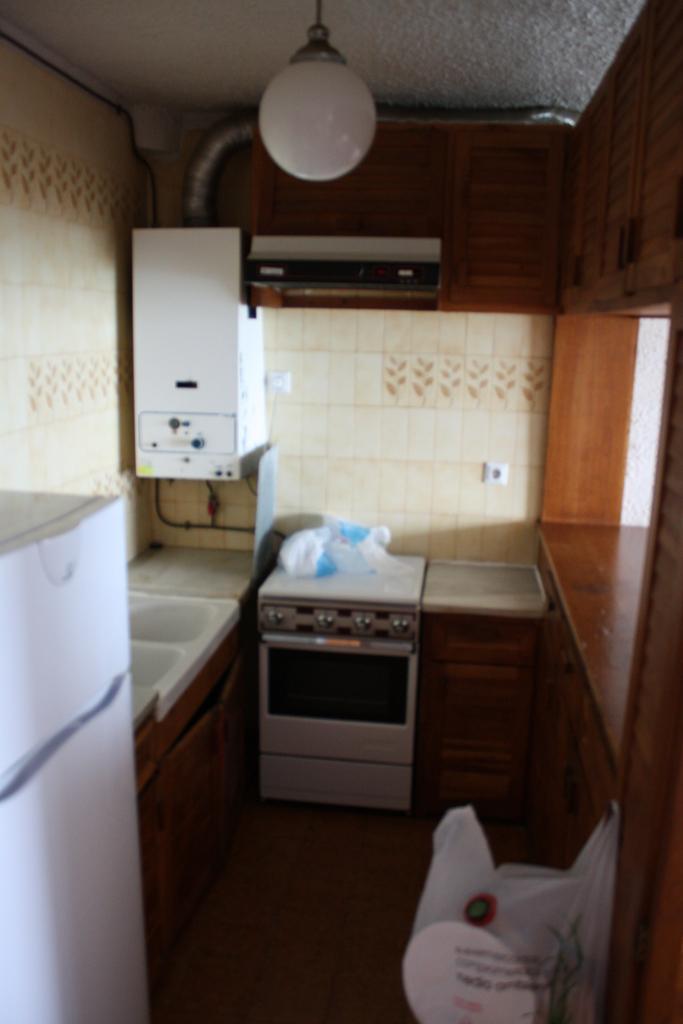Describe this image in one or two sentences. In this image there is kitchen, in this there is a fridge and a sink, behind the fridge there is a wall, in the background there is a microwave and there is a cupboard, under the cupboard there is a window. 